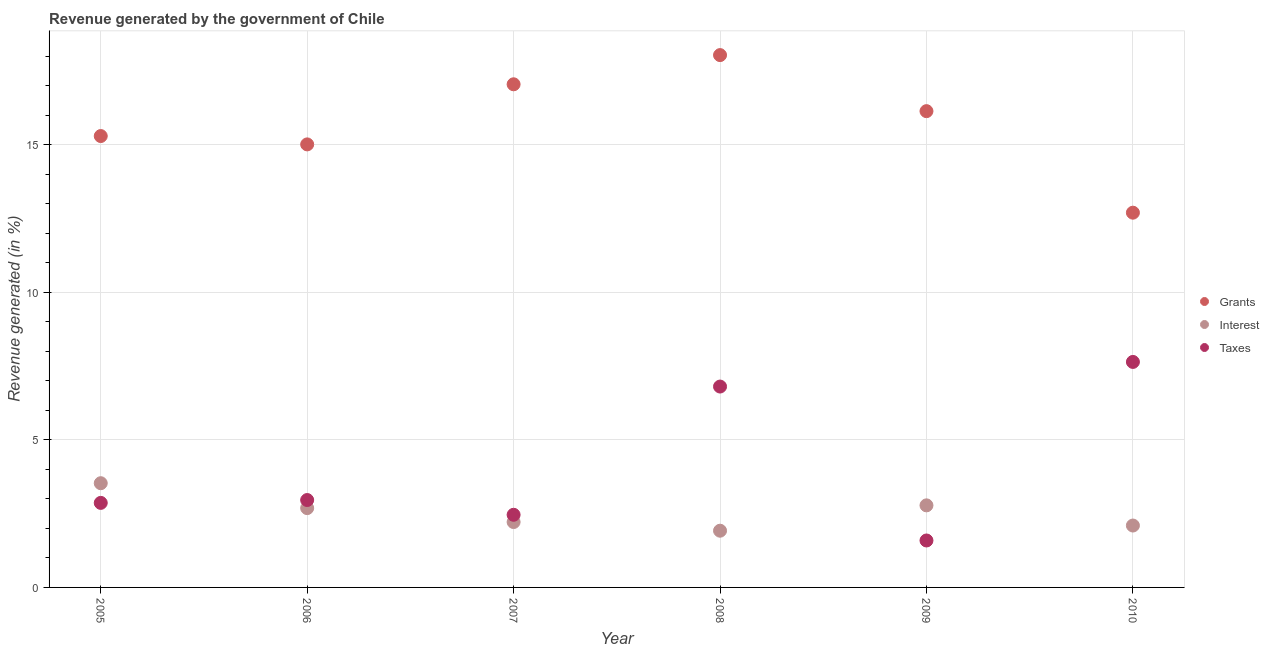What is the percentage of revenue generated by grants in 2005?
Your answer should be very brief. 15.29. Across all years, what is the maximum percentage of revenue generated by taxes?
Provide a succinct answer. 7.64. Across all years, what is the minimum percentage of revenue generated by grants?
Offer a very short reply. 12.7. In which year was the percentage of revenue generated by interest maximum?
Offer a terse response. 2005. In which year was the percentage of revenue generated by grants minimum?
Provide a short and direct response. 2010. What is the total percentage of revenue generated by interest in the graph?
Ensure brevity in your answer.  15.23. What is the difference between the percentage of revenue generated by taxes in 2005 and that in 2010?
Your answer should be very brief. -4.78. What is the difference between the percentage of revenue generated by interest in 2007 and the percentage of revenue generated by taxes in 2009?
Your response must be concise. 0.62. What is the average percentage of revenue generated by taxes per year?
Keep it short and to the point. 4.05. In the year 2006, what is the difference between the percentage of revenue generated by interest and percentage of revenue generated by taxes?
Your response must be concise. -0.27. What is the ratio of the percentage of revenue generated by interest in 2007 to that in 2010?
Your response must be concise. 1.06. Is the percentage of revenue generated by taxes in 2006 less than that in 2009?
Provide a succinct answer. No. What is the difference between the highest and the second highest percentage of revenue generated by taxes?
Offer a terse response. 0.83. What is the difference between the highest and the lowest percentage of revenue generated by taxes?
Offer a terse response. 6.05. Does the percentage of revenue generated by interest monotonically increase over the years?
Offer a terse response. No. Is the percentage of revenue generated by grants strictly less than the percentage of revenue generated by taxes over the years?
Offer a terse response. No. How many dotlines are there?
Provide a succinct answer. 3. Are the values on the major ticks of Y-axis written in scientific E-notation?
Ensure brevity in your answer.  No. How many legend labels are there?
Offer a very short reply. 3. What is the title of the graph?
Keep it short and to the point. Revenue generated by the government of Chile. Does "Hydroelectric sources" appear as one of the legend labels in the graph?
Ensure brevity in your answer.  No. What is the label or title of the Y-axis?
Keep it short and to the point. Revenue generated (in %). What is the Revenue generated (in %) in Grants in 2005?
Make the answer very short. 15.29. What is the Revenue generated (in %) in Interest in 2005?
Your answer should be very brief. 3.53. What is the Revenue generated (in %) of Taxes in 2005?
Make the answer very short. 2.86. What is the Revenue generated (in %) of Grants in 2006?
Provide a short and direct response. 15.01. What is the Revenue generated (in %) in Interest in 2006?
Provide a succinct answer. 2.69. What is the Revenue generated (in %) of Taxes in 2006?
Ensure brevity in your answer.  2.96. What is the Revenue generated (in %) of Grants in 2007?
Your answer should be compact. 17.05. What is the Revenue generated (in %) of Interest in 2007?
Give a very brief answer. 2.22. What is the Revenue generated (in %) of Taxes in 2007?
Make the answer very short. 2.46. What is the Revenue generated (in %) of Grants in 2008?
Make the answer very short. 18.03. What is the Revenue generated (in %) of Interest in 2008?
Provide a short and direct response. 1.92. What is the Revenue generated (in %) of Taxes in 2008?
Provide a succinct answer. 6.81. What is the Revenue generated (in %) of Grants in 2009?
Your answer should be very brief. 16.14. What is the Revenue generated (in %) of Interest in 2009?
Provide a short and direct response. 2.78. What is the Revenue generated (in %) of Taxes in 2009?
Provide a succinct answer. 1.59. What is the Revenue generated (in %) of Grants in 2010?
Keep it short and to the point. 12.7. What is the Revenue generated (in %) of Interest in 2010?
Your answer should be compact. 2.1. What is the Revenue generated (in %) of Taxes in 2010?
Offer a terse response. 7.64. Across all years, what is the maximum Revenue generated (in %) in Grants?
Offer a very short reply. 18.03. Across all years, what is the maximum Revenue generated (in %) of Interest?
Your answer should be compact. 3.53. Across all years, what is the maximum Revenue generated (in %) of Taxes?
Keep it short and to the point. 7.64. Across all years, what is the minimum Revenue generated (in %) of Grants?
Give a very brief answer. 12.7. Across all years, what is the minimum Revenue generated (in %) of Interest?
Provide a short and direct response. 1.92. Across all years, what is the minimum Revenue generated (in %) in Taxes?
Provide a short and direct response. 1.59. What is the total Revenue generated (in %) of Grants in the graph?
Offer a very short reply. 94.21. What is the total Revenue generated (in %) in Interest in the graph?
Offer a very short reply. 15.23. What is the total Revenue generated (in %) of Taxes in the graph?
Your answer should be very brief. 24.32. What is the difference between the Revenue generated (in %) of Grants in 2005 and that in 2006?
Offer a very short reply. 0.28. What is the difference between the Revenue generated (in %) of Interest in 2005 and that in 2006?
Ensure brevity in your answer.  0.84. What is the difference between the Revenue generated (in %) in Taxes in 2005 and that in 2006?
Ensure brevity in your answer.  -0.1. What is the difference between the Revenue generated (in %) of Grants in 2005 and that in 2007?
Provide a short and direct response. -1.75. What is the difference between the Revenue generated (in %) of Interest in 2005 and that in 2007?
Offer a terse response. 1.32. What is the difference between the Revenue generated (in %) of Taxes in 2005 and that in 2007?
Keep it short and to the point. 0.4. What is the difference between the Revenue generated (in %) in Grants in 2005 and that in 2008?
Offer a very short reply. -2.74. What is the difference between the Revenue generated (in %) in Interest in 2005 and that in 2008?
Your answer should be very brief. 1.61. What is the difference between the Revenue generated (in %) in Taxes in 2005 and that in 2008?
Offer a very short reply. -3.94. What is the difference between the Revenue generated (in %) of Grants in 2005 and that in 2009?
Your response must be concise. -0.84. What is the difference between the Revenue generated (in %) of Interest in 2005 and that in 2009?
Your response must be concise. 0.75. What is the difference between the Revenue generated (in %) in Taxes in 2005 and that in 2009?
Give a very brief answer. 1.27. What is the difference between the Revenue generated (in %) in Grants in 2005 and that in 2010?
Keep it short and to the point. 2.6. What is the difference between the Revenue generated (in %) of Interest in 2005 and that in 2010?
Your answer should be compact. 1.43. What is the difference between the Revenue generated (in %) of Taxes in 2005 and that in 2010?
Provide a short and direct response. -4.78. What is the difference between the Revenue generated (in %) of Grants in 2006 and that in 2007?
Offer a terse response. -2.04. What is the difference between the Revenue generated (in %) in Interest in 2006 and that in 2007?
Make the answer very short. 0.47. What is the difference between the Revenue generated (in %) of Grants in 2006 and that in 2008?
Your answer should be very brief. -3.03. What is the difference between the Revenue generated (in %) of Interest in 2006 and that in 2008?
Offer a terse response. 0.77. What is the difference between the Revenue generated (in %) in Taxes in 2006 and that in 2008?
Make the answer very short. -3.84. What is the difference between the Revenue generated (in %) in Grants in 2006 and that in 2009?
Give a very brief answer. -1.13. What is the difference between the Revenue generated (in %) of Interest in 2006 and that in 2009?
Keep it short and to the point. -0.09. What is the difference between the Revenue generated (in %) of Taxes in 2006 and that in 2009?
Offer a terse response. 1.37. What is the difference between the Revenue generated (in %) in Grants in 2006 and that in 2010?
Provide a succinct answer. 2.31. What is the difference between the Revenue generated (in %) in Interest in 2006 and that in 2010?
Provide a short and direct response. 0.59. What is the difference between the Revenue generated (in %) in Taxes in 2006 and that in 2010?
Your answer should be very brief. -4.68. What is the difference between the Revenue generated (in %) in Grants in 2007 and that in 2008?
Ensure brevity in your answer.  -0.99. What is the difference between the Revenue generated (in %) of Interest in 2007 and that in 2008?
Your response must be concise. 0.29. What is the difference between the Revenue generated (in %) of Taxes in 2007 and that in 2008?
Keep it short and to the point. -4.34. What is the difference between the Revenue generated (in %) in Grants in 2007 and that in 2009?
Provide a short and direct response. 0.91. What is the difference between the Revenue generated (in %) of Interest in 2007 and that in 2009?
Give a very brief answer. -0.57. What is the difference between the Revenue generated (in %) in Taxes in 2007 and that in 2009?
Provide a succinct answer. 0.87. What is the difference between the Revenue generated (in %) of Grants in 2007 and that in 2010?
Your answer should be very brief. 4.35. What is the difference between the Revenue generated (in %) in Interest in 2007 and that in 2010?
Give a very brief answer. 0.12. What is the difference between the Revenue generated (in %) of Taxes in 2007 and that in 2010?
Offer a very short reply. -5.18. What is the difference between the Revenue generated (in %) of Grants in 2008 and that in 2009?
Give a very brief answer. 1.9. What is the difference between the Revenue generated (in %) of Interest in 2008 and that in 2009?
Provide a succinct answer. -0.86. What is the difference between the Revenue generated (in %) in Taxes in 2008 and that in 2009?
Make the answer very short. 5.21. What is the difference between the Revenue generated (in %) of Grants in 2008 and that in 2010?
Give a very brief answer. 5.34. What is the difference between the Revenue generated (in %) of Interest in 2008 and that in 2010?
Ensure brevity in your answer.  -0.18. What is the difference between the Revenue generated (in %) in Taxes in 2008 and that in 2010?
Make the answer very short. -0.83. What is the difference between the Revenue generated (in %) of Grants in 2009 and that in 2010?
Give a very brief answer. 3.44. What is the difference between the Revenue generated (in %) in Interest in 2009 and that in 2010?
Your answer should be very brief. 0.68. What is the difference between the Revenue generated (in %) of Taxes in 2009 and that in 2010?
Provide a succinct answer. -6.05. What is the difference between the Revenue generated (in %) of Grants in 2005 and the Revenue generated (in %) of Interest in 2006?
Keep it short and to the point. 12.61. What is the difference between the Revenue generated (in %) of Grants in 2005 and the Revenue generated (in %) of Taxes in 2006?
Your response must be concise. 12.33. What is the difference between the Revenue generated (in %) of Interest in 2005 and the Revenue generated (in %) of Taxes in 2006?
Offer a very short reply. 0.57. What is the difference between the Revenue generated (in %) of Grants in 2005 and the Revenue generated (in %) of Interest in 2007?
Give a very brief answer. 13.08. What is the difference between the Revenue generated (in %) in Grants in 2005 and the Revenue generated (in %) in Taxes in 2007?
Offer a very short reply. 12.83. What is the difference between the Revenue generated (in %) of Interest in 2005 and the Revenue generated (in %) of Taxes in 2007?
Ensure brevity in your answer.  1.07. What is the difference between the Revenue generated (in %) of Grants in 2005 and the Revenue generated (in %) of Interest in 2008?
Your answer should be compact. 13.37. What is the difference between the Revenue generated (in %) in Grants in 2005 and the Revenue generated (in %) in Taxes in 2008?
Your answer should be compact. 8.49. What is the difference between the Revenue generated (in %) in Interest in 2005 and the Revenue generated (in %) in Taxes in 2008?
Provide a short and direct response. -3.27. What is the difference between the Revenue generated (in %) in Grants in 2005 and the Revenue generated (in %) in Interest in 2009?
Ensure brevity in your answer.  12.51. What is the difference between the Revenue generated (in %) of Grants in 2005 and the Revenue generated (in %) of Taxes in 2009?
Offer a terse response. 13.7. What is the difference between the Revenue generated (in %) of Interest in 2005 and the Revenue generated (in %) of Taxes in 2009?
Ensure brevity in your answer.  1.94. What is the difference between the Revenue generated (in %) in Grants in 2005 and the Revenue generated (in %) in Interest in 2010?
Provide a short and direct response. 13.19. What is the difference between the Revenue generated (in %) of Grants in 2005 and the Revenue generated (in %) of Taxes in 2010?
Your answer should be compact. 7.65. What is the difference between the Revenue generated (in %) of Interest in 2005 and the Revenue generated (in %) of Taxes in 2010?
Ensure brevity in your answer.  -4.11. What is the difference between the Revenue generated (in %) of Grants in 2006 and the Revenue generated (in %) of Interest in 2007?
Keep it short and to the point. 12.79. What is the difference between the Revenue generated (in %) in Grants in 2006 and the Revenue generated (in %) in Taxes in 2007?
Your response must be concise. 12.55. What is the difference between the Revenue generated (in %) in Interest in 2006 and the Revenue generated (in %) in Taxes in 2007?
Your response must be concise. 0.23. What is the difference between the Revenue generated (in %) in Grants in 2006 and the Revenue generated (in %) in Interest in 2008?
Make the answer very short. 13.09. What is the difference between the Revenue generated (in %) of Grants in 2006 and the Revenue generated (in %) of Taxes in 2008?
Provide a succinct answer. 8.2. What is the difference between the Revenue generated (in %) of Interest in 2006 and the Revenue generated (in %) of Taxes in 2008?
Offer a terse response. -4.12. What is the difference between the Revenue generated (in %) in Grants in 2006 and the Revenue generated (in %) in Interest in 2009?
Provide a short and direct response. 12.23. What is the difference between the Revenue generated (in %) of Grants in 2006 and the Revenue generated (in %) of Taxes in 2009?
Offer a terse response. 13.42. What is the difference between the Revenue generated (in %) in Interest in 2006 and the Revenue generated (in %) in Taxes in 2009?
Give a very brief answer. 1.1. What is the difference between the Revenue generated (in %) of Grants in 2006 and the Revenue generated (in %) of Interest in 2010?
Your response must be concise. 12.91. What is the difference between the Revenue generated (in %) of Grants in 2006 and the Revenue generated (in %) of Taxes in 2010?
Provide a short and direct response. 7.37. What is the difference between the Revenue generated (in %) in Interest in 2006 and the Revenue generated (in %) in Taxes in 2010?
Offer a terse response. -4.95. What is the difference between the Revenue generated (in %) of Grants in 2007 and the Revenue generated (in %) of Interest in 2008?
Make the answer very short. 15.12. What is the difference between the Revenue generated (in %) of Grants in 2007 and the Revenue generated (in %) of Taxes in 2008?
Ensure brevity in your answer.  10.24. What is the difference between the Revenue generated (in %) in Interest in 2007 and the Revenue generated (in %) in Taxes in 2008?
Your answer should be very brief. -4.59. What is the difference between the Revenue generated (in %) in Grants in 2007 and the Revenue generated (in %) in Interest in 2009?
Provide a succinct answer. 14.27. What is the difference between the Revenue generated (in %) of Grants in 2007 and the Revenue generated (in %) of Taxes in 2009?
Ensure brevity in your answer.  15.46. What is the difference between the Revenue generated (in %) in Interest in 2007 and the Revenue generated (in %) in Taxes in 2009?
Give a very brief answer. 0.62. What is the difference between the Revenue generated (in %) of Grants in 2007 and the Revenue generated (in %) of Interest in 2010?
Your answer should be very brief. 14.95. What is the difference between the Revenue generated (in %) in Grants in 2007 and the Revenue generated (in %) in Taxes in 2010?
Your response must be concise. 9.41. What is the difference between the Revenue generated (in %) in Interest in 2007 and the Revenue generated (in %) in Taxes in 2010?
Keep it short and to the point. -5.42. What is the difference between the Revenue generated (in %) of Grants in 2008 and the Revenue generated (in %) of Interest in 2009?
Provide a succinct answer. 15.25. What is the difference between the Revenue generated (in %) in Grants in 2008 and the Revenue generated (in %) in Taxes in 2009?
Give a very brief answer. 16.44. What is the difference between the Revenue generated (in %) of Interest in 2008 and the Revenue generated (in %) of Taxes in 2009?
Provide a succinct answer. 0.33. What is the difference between the Revenue generated (in %) of Grants in 2008 and the Revenue generated (in %) of Interest in 2010?
Your answer should be very brief. 15.94. What is the difference between the Revenue generated (in %) in Grants in 2008 and the Revenue generated (in %) in Taxes in 2010?
Offer a terse response. 10.4. What is the difference between the Revenue generated (in %) of Interest in 2008 and the Revenue generated (in %) of Taxes in 2010?
Give a very brief answer. -5.72. What is the difference between the Revenue generated (in %) in Grants in 2009 and the Revenue generated (in %) in Interest in 2010?
Your answer should be compact. 14.04. What is the difference between the Revenue generated (in %) of Grants in 2009 and the Revenue generated (in %) of Taxes in 2010?
Offer a very short reply. 8.5. What is the difference between the Revenue generated (in %) of Interest in 2009 and the Revenue generated (in %) of Taxes in 2010?
Keep it short and to the point. -4.86. What is the average Revenue generated (in %) in Grants per year?
Offer a very short reply. 15.7. What is the average Revenue generated (in %) in Interest per year?
Provide a short and direct response. 2.54. What is the average Revenue generated (in %) of Taxes per year?
Ensure brevity in your answer.  4.05. In the year 2005, what is the difference between the Revenue generated (in %) of Grants and Revenue generated (in %) of Interest?
Give a very brief answer. 11.76. In the year 2005, what is the difference between the Revenue generated (in %) in Grants and Revenue generated (in %) in Taxes?
Make the answer very short. 12.43. In the year 2005, what is the difference between the Revenue generated (in %) of Interest and Revenue generated (in %) of Taxes?
Ensure brevity in your answer.  0.67. In the year 2006, what is the difference between the Revenue generated (in %) in Grants and Revenue generated (in %) in Interest?
Provide a succinct answer. 12.32. In the year 2006, what is the difference between the Revenue generated (in %) of Grants and Revenue generated (in %) of Taxes?
Your answer should be very brief. 12.05. In the year 2006, what is the difference between the Revenue generated (in %) of Interest and Revenue generated (in %) of Taxes?
Make the answer very short. -0.27. In the year 2007, what is the difference between the Revenue generated (in %) of Grants and Revenue generated (in %) of Interest?
Ensure brevity in your answer.  14.83. In the year 2007, what is the difference between the Revenue generated (in %) in Grants and Revenue generated (in %) in Taxes?
Give a very brief answer. 14.58. In the year 2007, what is the difference between the Revenue generated (in %) of Interest and Revenue generated (in %) of Taxes?
Make the answer very short. -0.25. In the year 2008, what is the difference between the Revenue generated (in %) of Grants and Revenue generated (in %) of Interest?
Your answer should be compact. 16.11. In the year 2008, what is the difference between the Revenue generated (in %) in Grants and Revenue generated (in %) in Taxes?
Keep it short and to the point. 11.23. In the year 2008, what is the difference between the Revenue generated (in %) in Interest and Revenue generated (in %) in Taxes?
Your answer should be very brief. -4.88. In the year 2009, what is the difference between the Revenue generated (in %) in Grants and Revenue generated (in %) in Interest?
Provide a succinct answer. 13.36. In the year 2009, what is the difference between the Revenue generated (in %) of Grants and Revenue generated (in %) of Taxes?
Give a very brief answer. 14.54. In the year 2009, what is the difference between the Revenue generated (in %) of Interest and Revenue generated (in %) of Taxes?
Your answer should be very brief. 1.19. In the year 2010, what is the difference between the Revenue generated (in %) of Grants and Revenue generated (in %) of Interest?
Provide a succinct answer. 10.6. In the year 2010, what is the difference between the Revenue generated (in %) in Grants and Revenue generated (in %) in Taxes?
Provide a succinct answer. 5.06. In the year 2010, what is the difference between the Revenue generated (in %) of Interest and Revenue generated (in %) of Taxes?
Offer a terse response. -5.54. What is the ratio of the Revenue generated (in %) in Grants in 2005 to that in 2006?
Make the answer very short. 1.02. What is the ratio of the Revenue generated (in %) of Interest in 2005 to that in 2006?
Ensure brevity in your answer.  1.31. What is the ratio of the Revenue generated (in %) of Taxes in 2005 to that in 2006?
Provide a succinct answer. 0.97. What is the ratio of the Revenue generated (in %) in Grants in 2005 to that in 2007?
Offer a very short reply. 0.9. What is the ratio of the Revenue generated (in %) in Interest in 2005 to that in 2007?
Provide a succinct answer. 1.59. What is the ratio of the Revenue generated (in %) in Taxes in 2005 to that in 2007?
Give a very brief answer. 1.16. What is the ratio of the Revenue generated (in %) in Grants in 2005 to that in 2008?
Keep it short and to the point. 0.85. What is the ratio of the Revenue generated (in %) of Interest in 2005 to that in 2008?
Your answer should be compact. 1.84. What is the ratio of the Revenue generated (in %) of Taxes in 2005 to that in 2008?
Your response must be concise. 0.42. What is the ratio of the Revenue generated (in %) of Grants in 2005 to that in 2009?
Offer a very short reply. 0.95. What is the ratio of the Revenue generated (in %) in Interest in 2005 to that in 2009?
Keep it short and to the point. 1.27. What is the ratio of the Revenue generated (in %) of Taxes in 2005 to that in 2009?
Provide a short and direct response. 1.8. What is the ratio of the Revenue generated (in %) of Grants in 2005 to that in 2010?
Your answer should be very brief. 1.2. What is the ratio of the Revenue generated (in %) of Interest in 2005 to that in 2010?
Keep it short and to the point. 1.68. What is the ratio of the Revenue generated (in %) of Taxes in 2005 to that in 2010?
Provide a succinct answer. 0.37. What is the ratio of the Revenue generated (in %) in Grants in 2006 to that in 2007?
Your answer should be very brief. 0.88. What is the ratio of the Revenue generated (in %) of Interest in 2006 to that in 2007?
Keep it short and to the point. 1.21. What is the ratio of the Revenue generated (in %) of Taxes in 2006 to that in 2007?
Provide a short and direct response. 1.2. What is the ratio of the Revenue generated (in %) of Grants in 2006 to that in 2008?
Provide a succinct answer. 0.83. What is the ratio of the Revenue generated (in %) in Interest in 2006 to that in 2008?
Provide a succinct answer. 1.4. What is the ratio of the Revenue generated (in %) of Taxes in 2006 to that in 2008?
Provide a succinct answer. 0.44. What is the ratio of the Revenue generated (in %) in Grants in 2006 to that in 2009?
Give a very brief answer. 0.93. What is the ratio of the Revenue generated (in %) of Interest in 2006 to that in 2009?
Keep it short and to the point. 0.97. What is the ratio of the Revenue generated (in %) of Taxes in 2006 to that in 2009?
Provide a succinct answer. 1.86. What is the ratio of the Revenue generated (in %) in Grants in 2006 to that in 2010?
Ensure brevity in your answer.  1.18. What is the ratio of the Revenue generated (in %) of Interest in 2006 to that in 2010?
Your answer should be compact. 1.28. What is the ratio of the Revenue generated (in %) of Taxes in 2006 to that in 2010?
Give a very brief answer. 0.39. What is the ratio of the Revenue generated (in %) of Grants in 2007 to that in 2008?
Provide a short and direct response. 0.95. What is the ratio of the Revenue generated (in %) of Interest in 2007 to that in 2008?
Your response must be concise. 1.15. What is the ratio of the Revenue generated (in %) of Taxes in 2007 to that in 2008?
Provide a succinct answer. 0.36. What is the ratio of the Revenue generated (in %) of Grants in 2007 to that in 2009?
Give a very brief answer. 1.06. What is the ratio of the Revenue generated (in %) in Interest in 2007 to that in 2009?
Your response must be concise. 0.8. What is the ratio of the Revenue generated (in %) in Taxes in 2007 to that in 2009?
Ensure brevity in your answer.  1.55. What is the ratio of the Revenue generated (in %) in Grants in 2007 to that in 2010?
Make the answer very short. 1.34. What is the ratio of the Revenue generated (in %) in Interest in 2007 to that in 2010?
Provide a succinct answer. 1.06. What is the ratio of the Revenue generated (in %) in Taxes in 2007 to that in 2010?
Keep it short and to the point. 0.32. What is the ratio of the Revenue generated (in %) of Grants in 2008 to that in 2009?
Your answer should be very brief. 1.12. What is the ratio of the Revenue generated (in %) in Interest in 2008 to that in 2009?
Provide a short and direct response. 0.69. What is the ratio of the Revenue generated (in %) of Taxes in 2008 to that in 2009?
Offer a terse response. 4.28. What is the ratio of the Revenue generated (in %) of Grants in 2008 to that in 2010?
Offer a terse response. 1.42. What is the ratio of the Revenue generated (in %) in Interest in 2008 to that in 2010?
Give a very brief answer. 0.92. What is the ratio of the Revenue generated (in %) in Taxes in 2008 to that in 2010?
Your answer should be compact. 0.89. What is the ratio of the Revenue generated (in %) of Grants in 2009 to that in 2010?
Your answer should be compact. 1.27. What is the ratio of the Revenue generated (in %) of Interest in 2009 to that in 2010?
Offer a terse response. 1.33. What is the ratio of the Revenue generated (in %) of Taxes in 2009 to that in 2010?
Offer a very short reply. 0.21. What is the difference between the highest and the second highest Revenue generated (in %) in Grants?
Offer a terse response. 0.99. What is the difference between the highest and the second highest Revenue generated (in %) of Interest?
Ensure brevity in your answer.  0.75. What is the difference between the highest and the second highest Revenue generated (in %) in Taxes?
Ensure brevity in your answer.  0.83. What is the difference between the highest and the lowest Revenue generated (in %) of Grants?
Ensure brevity in your answer.  5.34. What is the difference between the highest and the lowest Revenue generated (in %) of Interest?
Offer a very short reply. 1.61. What is the difference between the highest and the lowest Revenue generated (in %) in Taxes?
Ensure brevity in your answer.  6.05. 